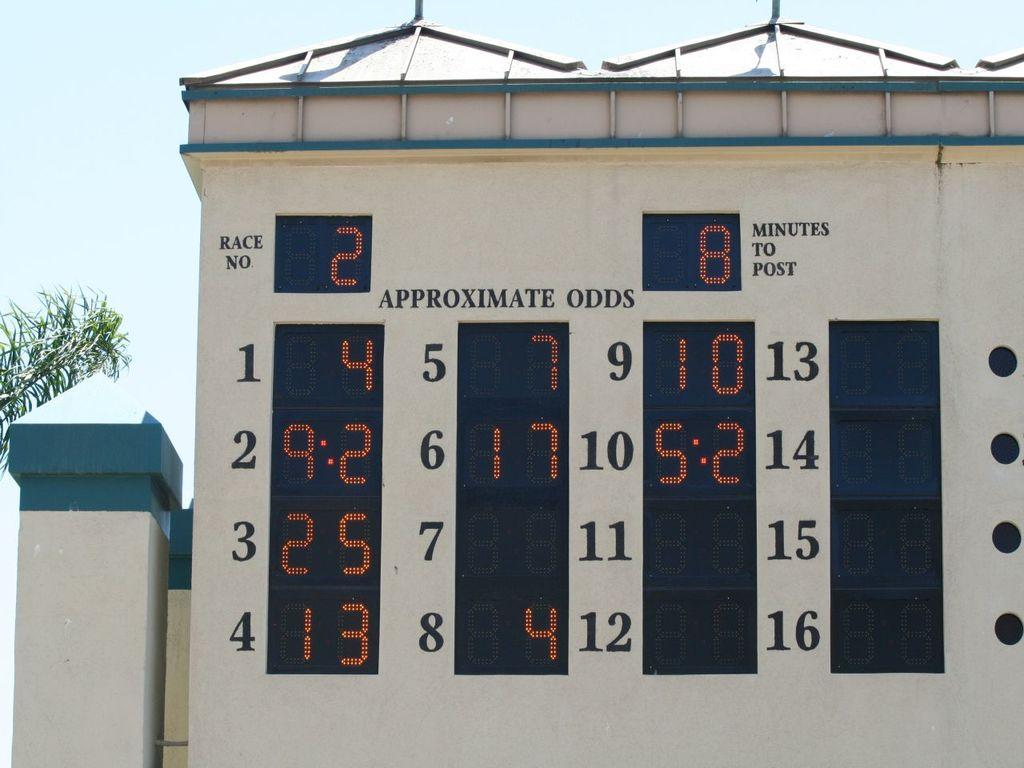<image>
Offer a succinct explanation of the picture presented. wall with electronic board showing the odds for race number 2 